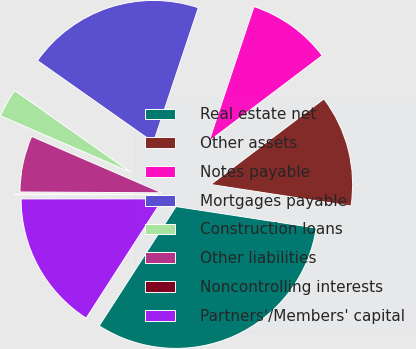Convert chart. <chart><loc_0><loc_0><loc_500><loc_500><pie_chart><fcel>Real estate net<fcel>Other assets<fcel>Notes payable<fcel>Mortgages payable<fcel>Construction loans<fcel>Other liabilities<fcel>Noncontrolling interests<fcel>Partners'/Members' capital<nl><fcel>31.68%<fcel>12.73%<fcel>9.57%<fcel>20.36%<fcel>3.26%<fcel>6.41%<fcel>0.1%<fcel>15.89%<nl></chart> 